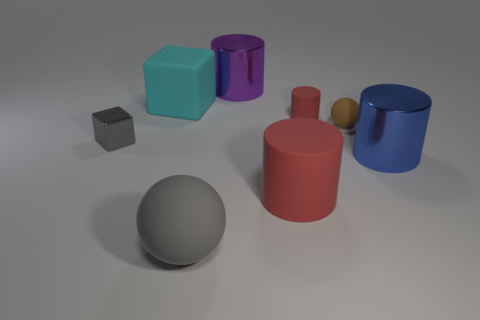Subtract 1 cylinders. How many cylinders are left? 3 Add 2 purple metallic balls. How many objects exist? 10 Subtract all balls. How many objects are left? 6 Add 2 tiny matte cylinders. How many tiny matte cylinders are left? 3 Add 3 large cyan rubber cubes. How many large cyan rubber cubes exist? 4 Subtract 0 red cubes. How many objects are left? 8 Subtract all small brown balls. Subtract all big purple cylinders. How many objects are left? 6 